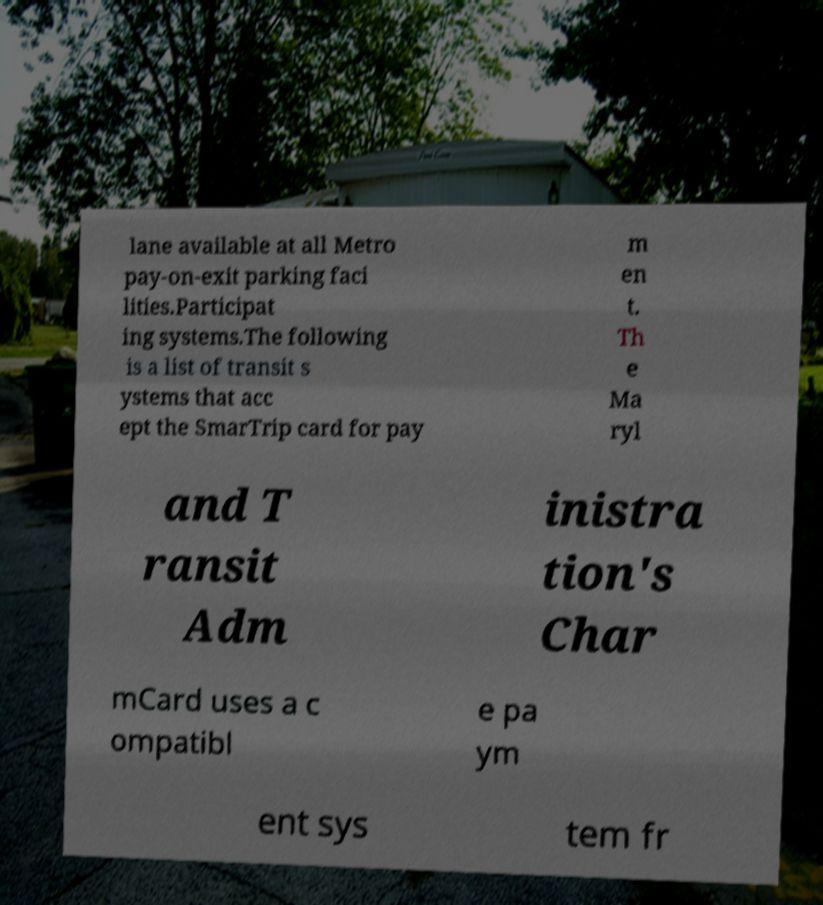Could you assist in decoding the text presented in this image and type it out clearly? lane available at all Metro pay-on-exit parking faci lities.Participat ing systems.The following is a list of transit s ystems that acc ept the SmarTrip card for pay m en t. Th e Ma ryl and T ransit Adm inistra tion's Char mCard uses a c ompatibl e pa ym ent sys tem fr 